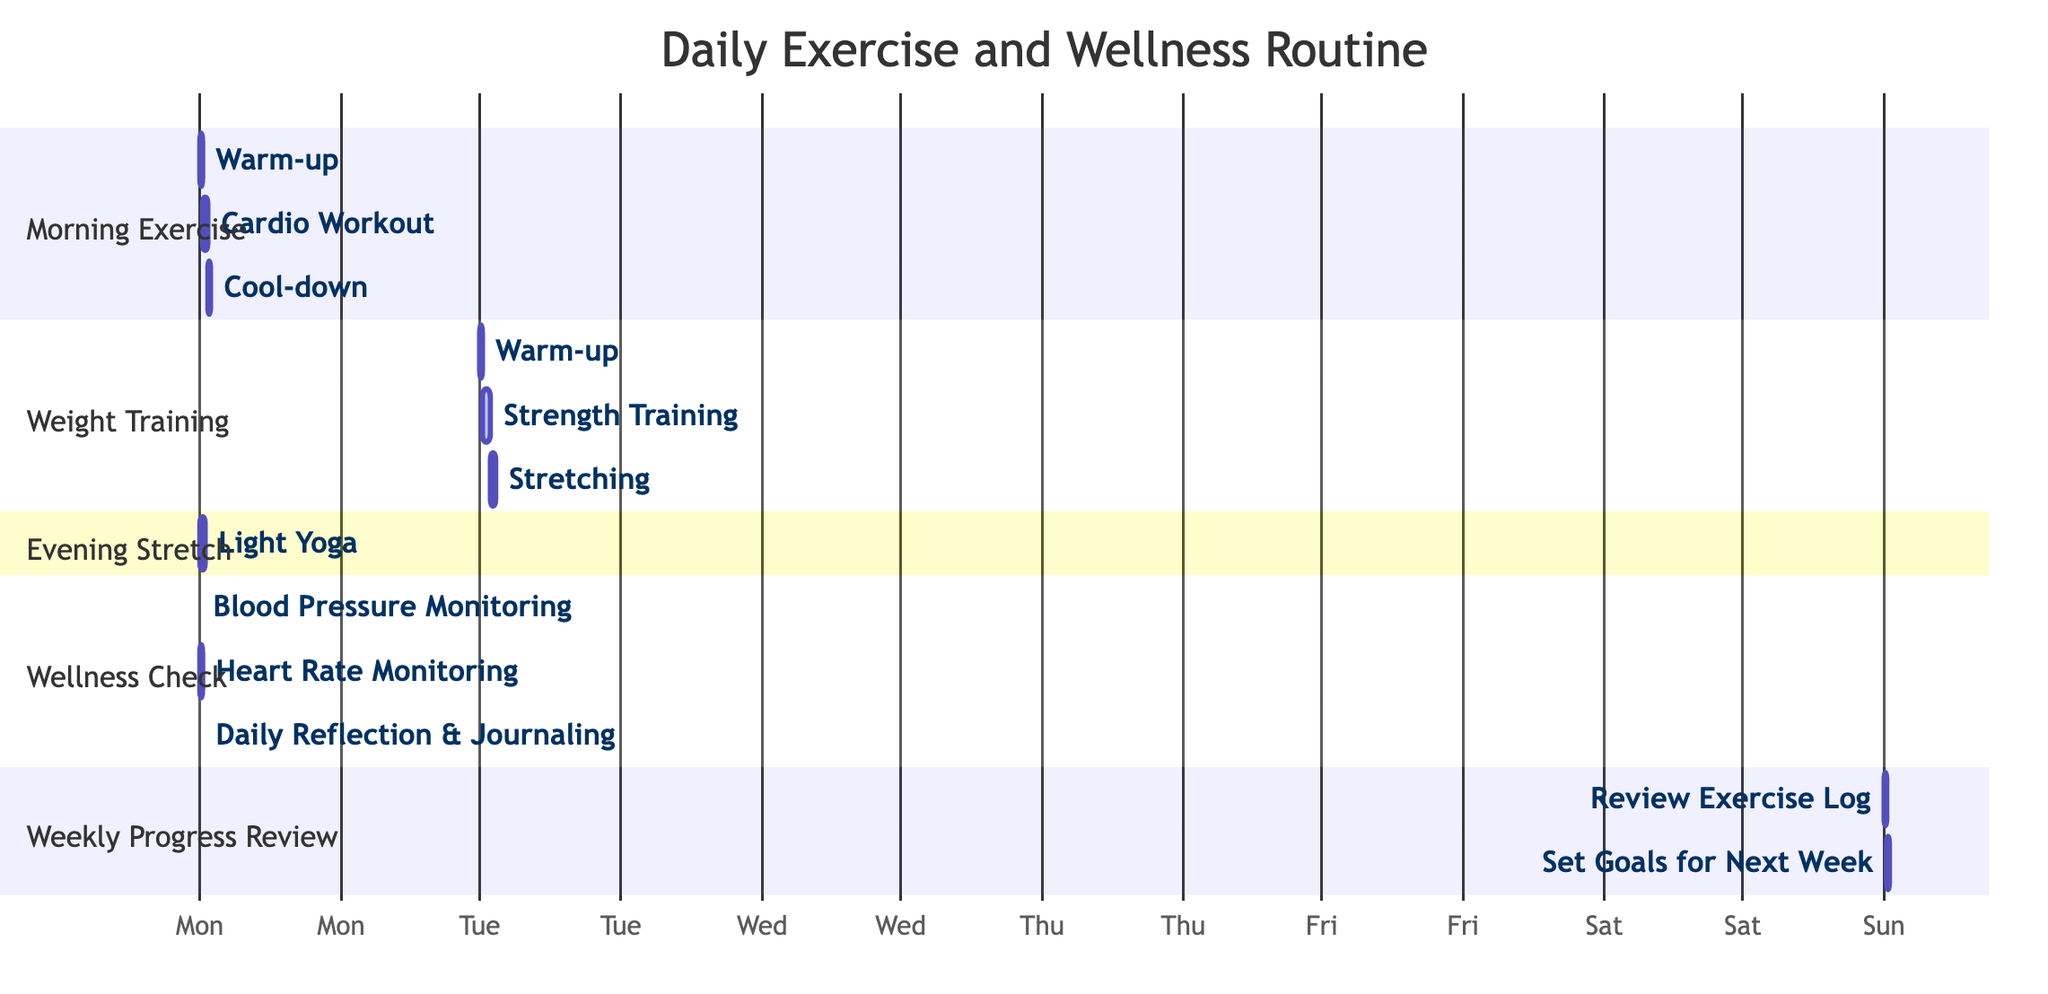What is the total duration of the Morning Exercise? The Morning Exercise consists of a warm-up (15 minutes), cardio workout (30 minutes), and cool-down (10 minutes). To find the total duration, we sum these times: 15 + 30 + 10 = 55 minutes.
Answer: 55 minutes How many days is the Weight Training scheduled for? Weight Training is set for Tuesday, Thursday, and Saturday. Counting these gives a total of 3 days.
Answer: 3 days What activity happens after Blood Pressure Monitoring? Blood Pressure Monitoring (5 minutes) is immediately followed by Heart Rate Monitoring (5 minutes). This shows the sequence in which they occur.
Answer: Heart Rate Monitoring Which day includes the Weekly Progress Review? The Weekly Progress Review is scheduled only for Sunday, making it the designated day for this activity.
Answer: Sunday How long is the Evening Stretch scheduled for? The Evening Stretch includes Light Yoga, which is scheduled for 30 minutes. Hence, the duration is specific to this activity.
Answer: 30 minutes What is the total duration of Wellness Check activities? The Wellness Check includes Blood Pressure Monitoring (5 minutes), Heart Rate Monitoring (5 minutes), and Daily Reflection & Journaling (10 minutes). Adding these gives: 5 + 5 + 10 = 20 minutes.
Answer: 20 minutes Which exercise routine includes Stretching? Stretching is a part of the Weight Training routine, as shown in the task list where it follows the Strength Training activity.
Answer: Weight Training What is the last activity of the Weekly Progress Review? The last activity listed under Weekly Progress Review is "Set Goals for Next Week," occurring after "Review Exercise Log." This indicates its position at the end of the review session.
Answer: Set Goals for Next Week What is the activity that occurs before Cardio Workout? The activity preceding Cardio Workout in the Morning Exercise is Warm-up, which takes 15 minutes. Consequently, this is its direct predecessor activity.
Answer: Warm-up 